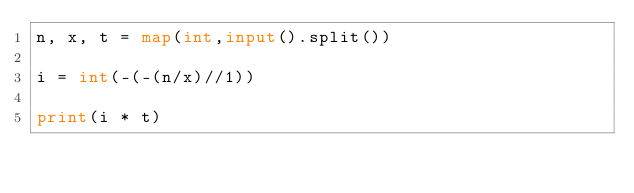Convert code to text. <code><loc_0><loc_0><loc_500><loc_500><_Python_>n, x, t = map(int,input().split())

i = int(-(-(n/x)//1))

print(i * t)</code> 